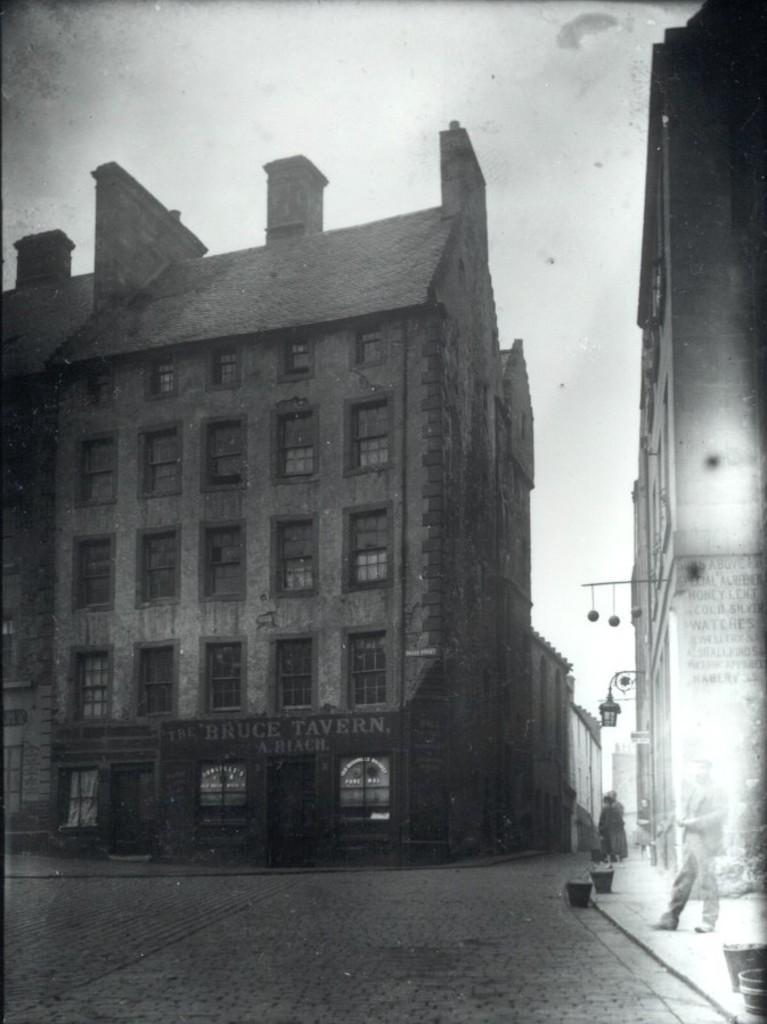Could you give a brief overview of what you see in this image? There are building with the windows, this is road and a sky. 